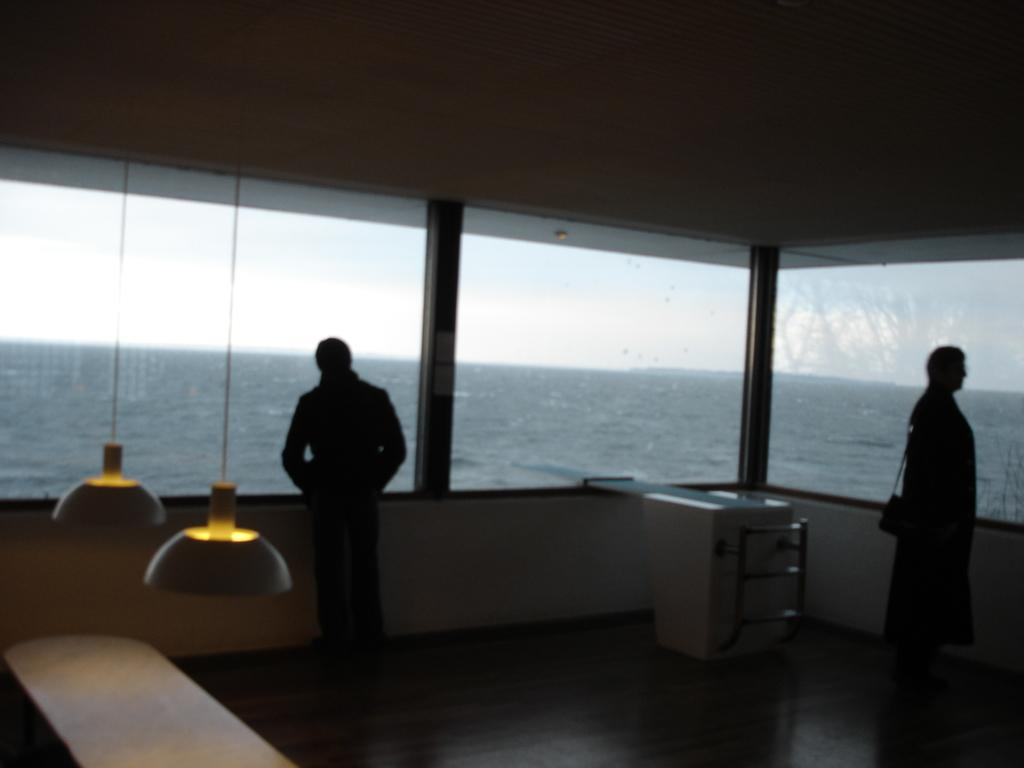What is located in the center of the image? There is a wall in the center of the image. What material is present in the image that allows for visibility? There is glass in the image. What can be seen illuminated in the image? There are lights in the image. What type of furniture is present in the image? There are tables in the image. How many people are in the image? Two persons are standing in the image. What can be seen through the glass in the image? The sky and water are visible through the glass. What type of loaf is being used as a front for the competition in the image? There is no loaf or competition present in the image. 